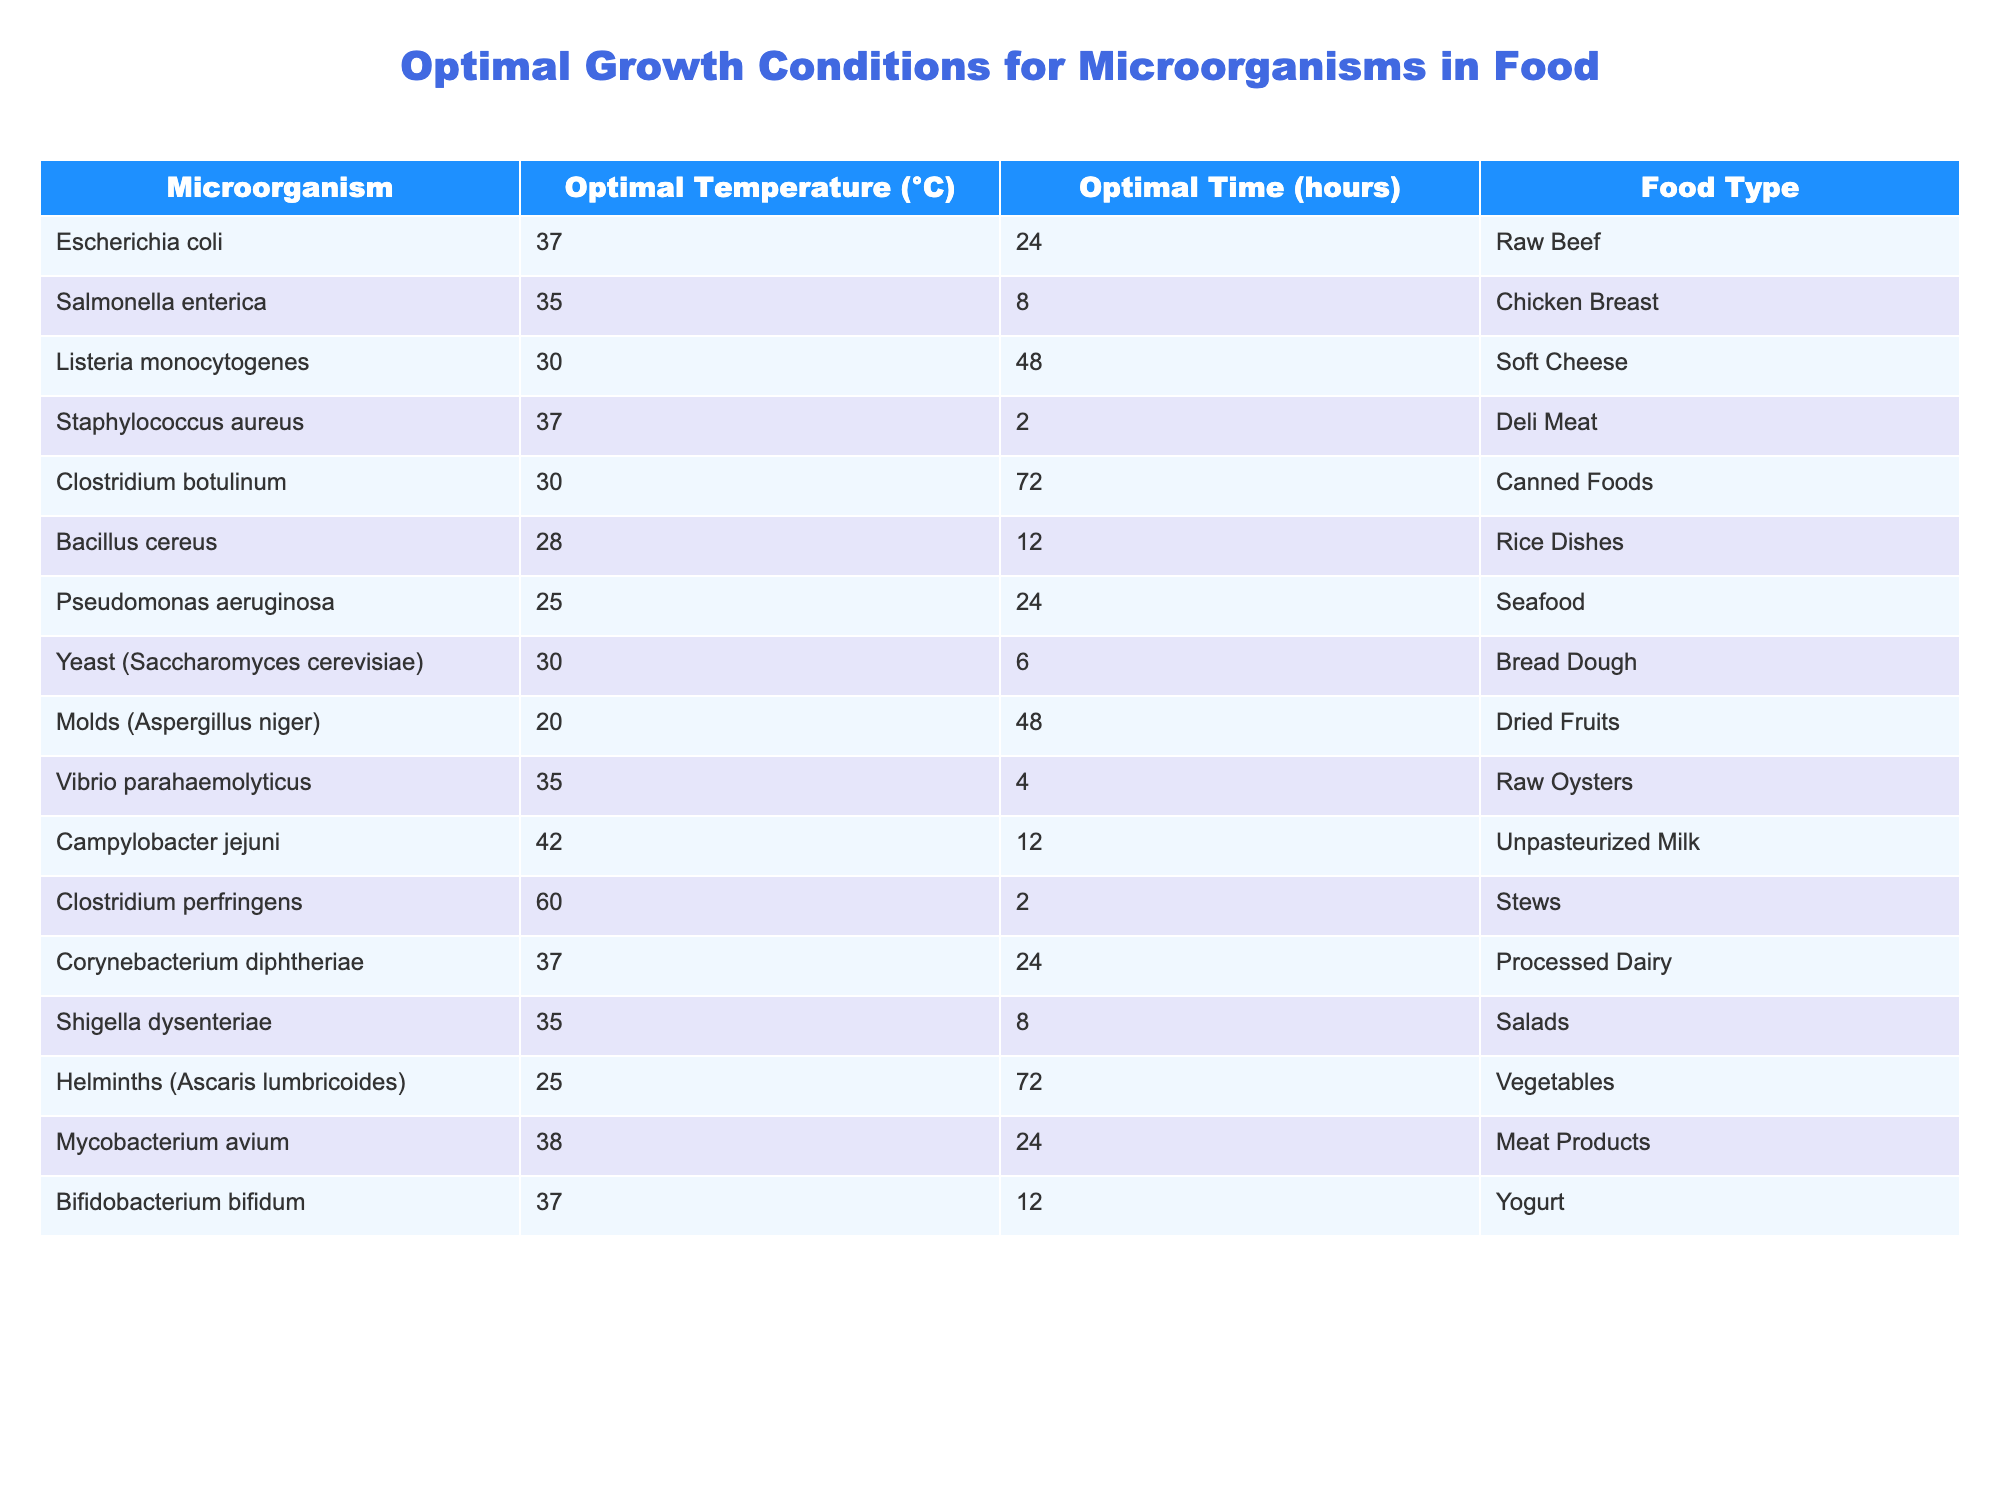What is the optimal temperature for Escherichia coli growth? According to the table, Escherichia coli has an optimal temperature of 37°C.
Answer: 37°C Which microorganism grows optimally at 30°C? Referring to the table, both Listeria monocytogenes and Clostridium botulinum are listed as having an optimal temperature of 30°C.
Answer: Listeria monocytogenes and Clostridium botulinum What is the optimal time for Salmonella enterica growth? The table indicates that the optimal time for Salmonella enterica is 8 hours.
Answer: 8 hours Which food type is associated with Clostridium botulinum? Looking at the table, Clostridium botulinum is associated with canned foods.
Answer: Canned Foods How many microorganisms have an optimal growth time of 24 hours? From the table, Escherichia coli, Pseudomonas aeruginosa, and Mycobacterium avium all have an optimal growth time of 24 hours, making a total of three.
Answer: 3 Which microorganism has the shortest optimal time for growth, and what is that time? By checking the table, Staphylococcus aureus has the shortest optimal growth time of 2 hours.
Answer: Staphylococcus aureus, 2 hours Is the optimal temperature for Clostridium perfringens higher than 40°C? The table shows that Clostridium perfringens has an optimal temperature of 60°C, which is indeed higher than 40°C.
Answer: Yes What is the range of optimal growth temperatures for the listed microorganisms? The optimal temperatures range from 20°C (for Molds) to 60°C (for Clostridium perfringens), giving a range of 40°C.
Answer: 40°C How much longer can Listeria monocytogenes grow compared to Staphylococcus aureus? The optimal time for Listeria monocytogenes is 48 hours, while Staphylococcus aureus is 2 hours, resulting in a difference of 46 hours.
Answer: 46 hours Which microorganism associated with seafood has the shortest optimal growth time? The table shows that Vibrio parahaemolyticus, associated with seafood, has an optimal growth time of 4 hours, making it the shortest among seafood microorganisms.
Answer: Vibrio parahaemolyticus, 4 hours 